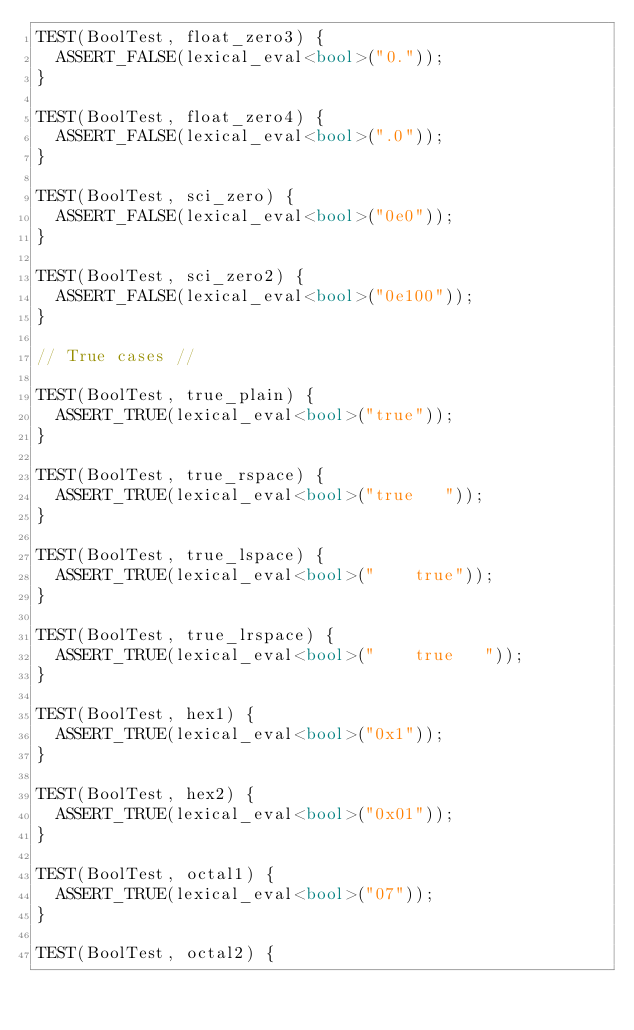<code> <loc_0><loc_0><loc_500><loc_500><_C++_>TEST(BoolTest, float_zero3) {
  ASSERT_FALSE(lexical_eval<bool>("0."));
}

TEST(BoolTest, float_zero4) {
  ASSERT_FALSE(lexical_eval<bool>(".0"));
}

TEST(BoolTest, sci_zero) {
  ASSERT_FALSE(lexical_eval<bool>("0e0"));
}

TEST(BoolTest, sci_zero2) {
  ASSERT_FALSE(lexical_eval<bool>("0e100"));
}

// True cases //

TEST(BoolTest, true_plain) {
  ASSERT_TRUE(lexical_eval<bool>("true"));
}

TEST(BoolTest, true_rspace) {
  ASSERT_TRUE(lexical_eval<bool>("true   "));
}

TEST(BoolTest, true_lspace) {
  ASSERT_TRUE(lexical_eval<bool>("    true"));
}

TEST(BoolTest, true_lrspace) {
  ASSERT_TRUE(lexical_eval<bool>("    true   "));
}

TEST(BoolTest, hex1) {
  ASSERT_TRUE(lexical_eval<bool>("0x1"));
}

TEST(BoolTest, hex2) {
  ASSERT_TRUE(lexical_eval<bool>("0x01"));
}

TEST(BoolTest, octal1) {
  ASSERT_TRUE(lexical_eval<bool>("07"));
}

TEST(BoolTest, octal2) {</code> 